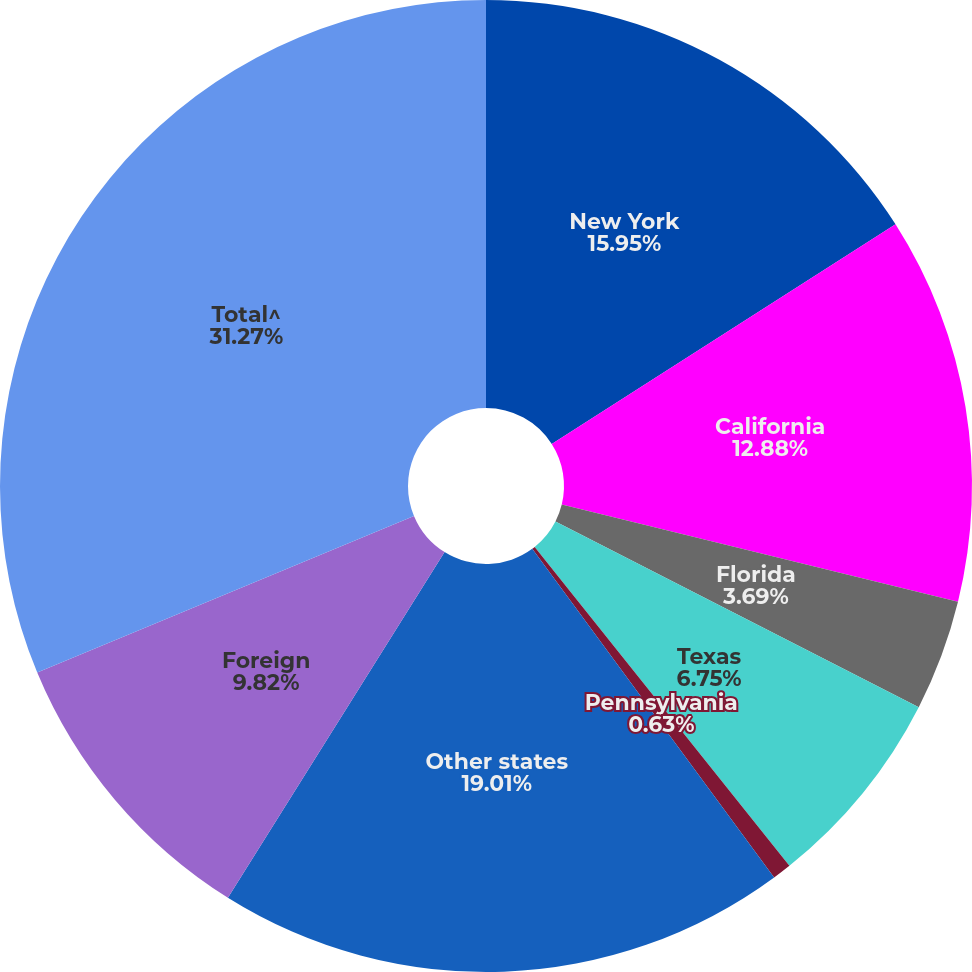Convert chart to OTSL. <chart><loc_0><loc_0><loc_500><loc_500><pie_chart><fcel>New York<fcel>California<fcel>Florida<fcel>Texas<fcel>Pennsylvania<fcel>Other states<fcel>Foreign<fcel>Total^<nl><fcel>15.95%<fcel>12.88%<fcel>3.69%<fcel>6.75%<fcel>0.63%<fcel>19.01%<fcel>9.82%<fcel>31.27%<nl></chart> 